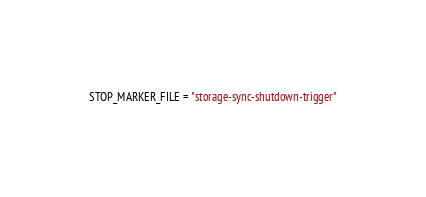Convert code to text. <code><loc_0><loc_0><loc_500><loc_500><_Python_>STOP_MARKER_FILE = "storage-sync-shutdown-trigger"
</code> 